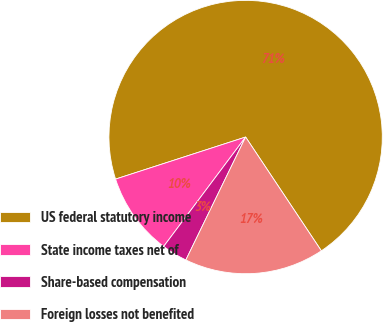Convert chart to OTSL. <chart><loc_0><loc_0><loc_500><loc_500><pie_chart><fcel>US federal statutory income<fcel>State income taxes net of<fcel>Share-based compensation<fcel>Foreign losses not benefited<nl><fcel>70.64%<fcel>9.79%<fcel>3.03%<fcel>16.55%<nl></chart> 